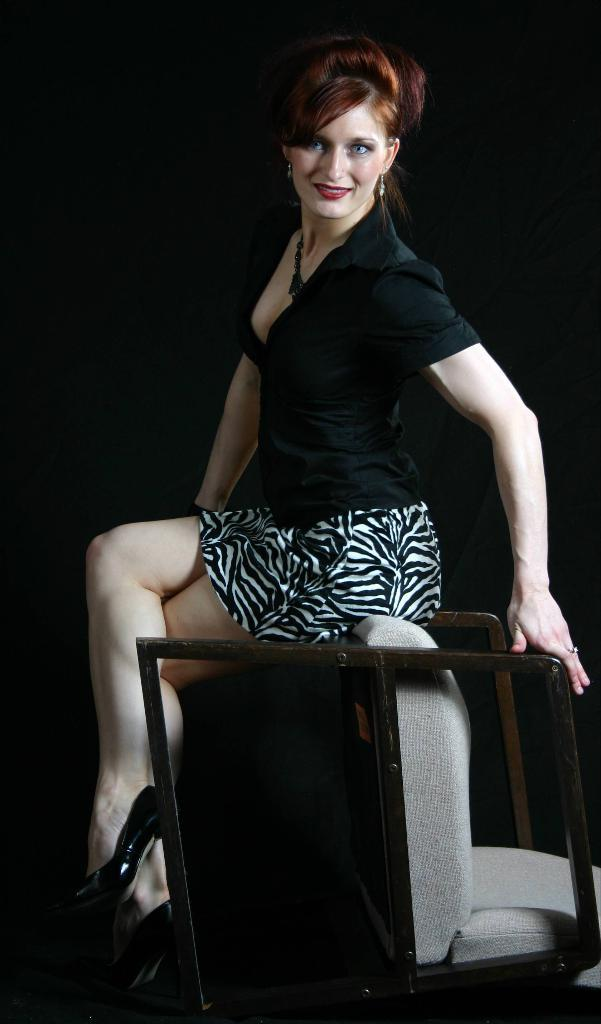Who is the main subject in the image? There is a woman in the image. What is the woman wearing? The woman is wearing a black dress. What is the woman's facial expression? The woman is smiling. What is the woman sitting on in the image? The woman is sitting on a chair. What color is the crayon the woman is holding in the image? There is no crayon present in the image. What advice does the woman's grandfather give her in the image? There is no mention of a grandfather or any advice in the image. What type of drug is the woman taking in the image? There is no drug present in the image. 